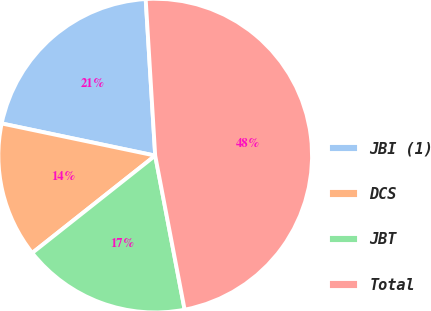Convert chart to OTSL. <chart><loc_0><loc_0><loc_500><loc_500><pie_chart><fcel>JBI (1)<fcel>DCS<fcel>JBT<fcel>Total<nl><fcel>20.75%<fcel>13.94%<fcel>17.35%<fcel>47.96%<nl></chart> 